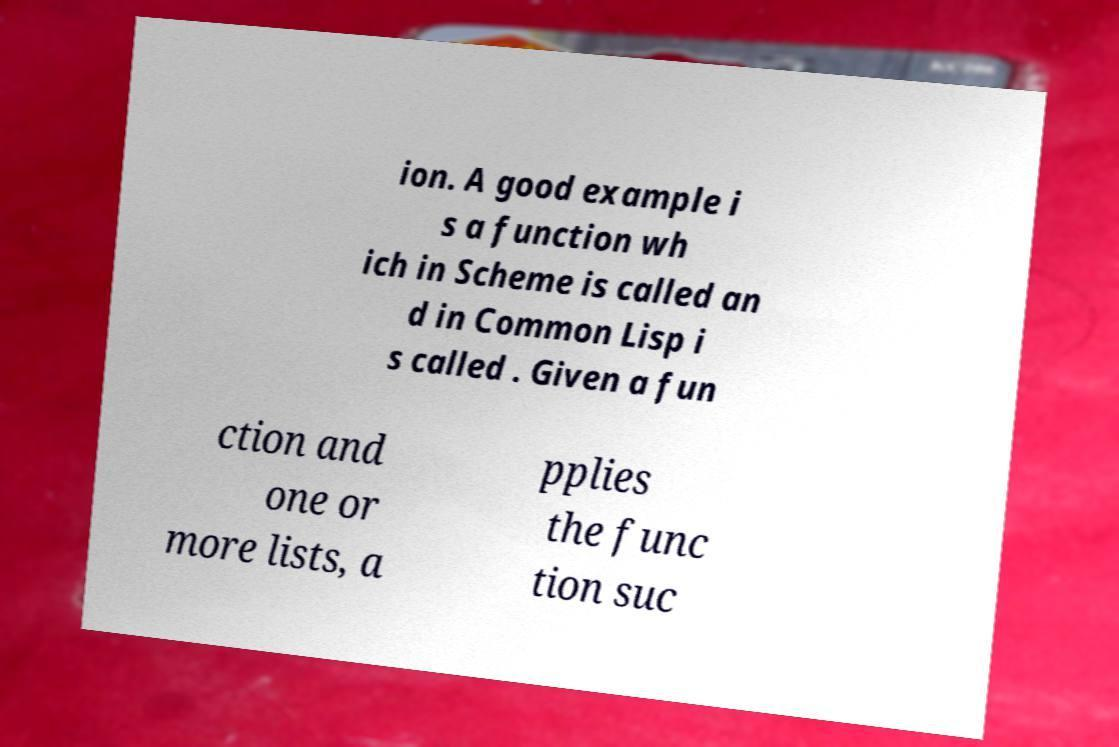There's text embedded in this image that I need extracted. Can you transcribe it verbatim? ion. A good example i s a function wh ich in Scheme is called an d in Common Lisp i s called . Given a fun ction and one or more lists, a pplies the func tion suc 